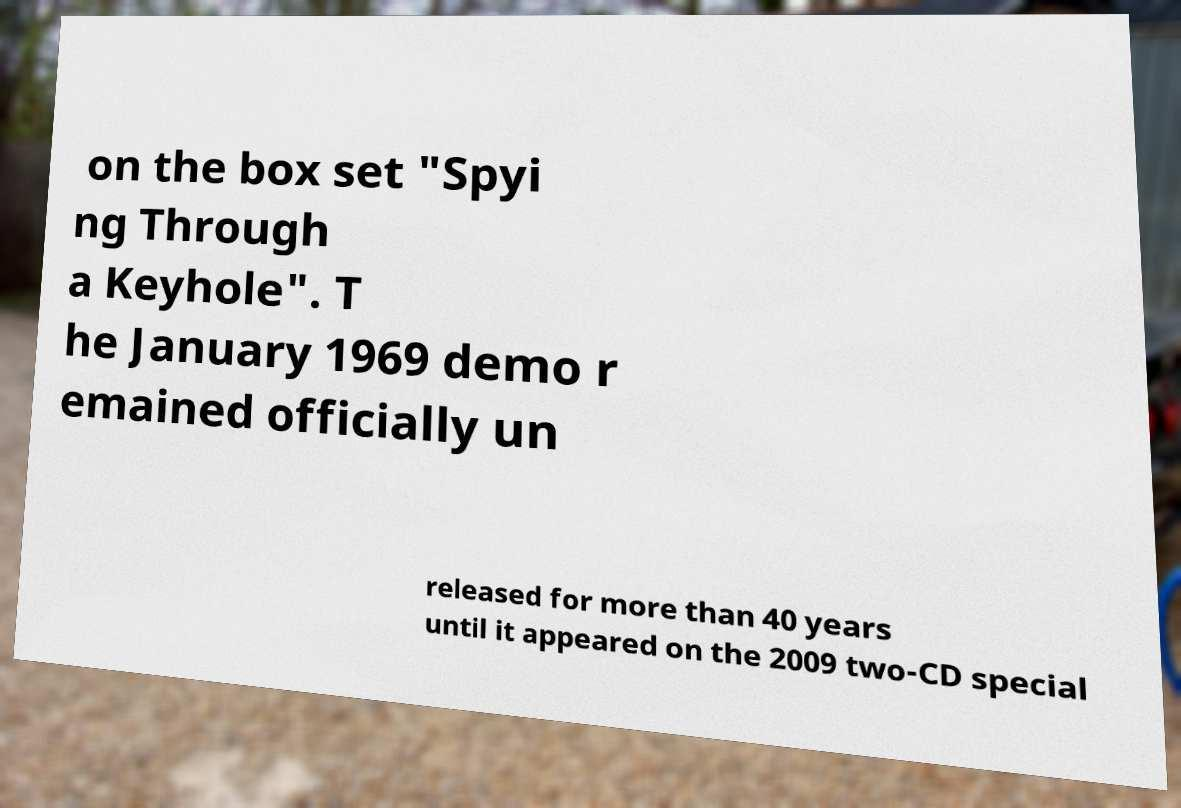What messages or text are displayed in this image? I need them in a readable, typed format. on the box set "Spyi ng Through a Keyhole". T he January 1969 demo r emained officially un released for more than 40 years until it appeared on the 2009 two-CD special 